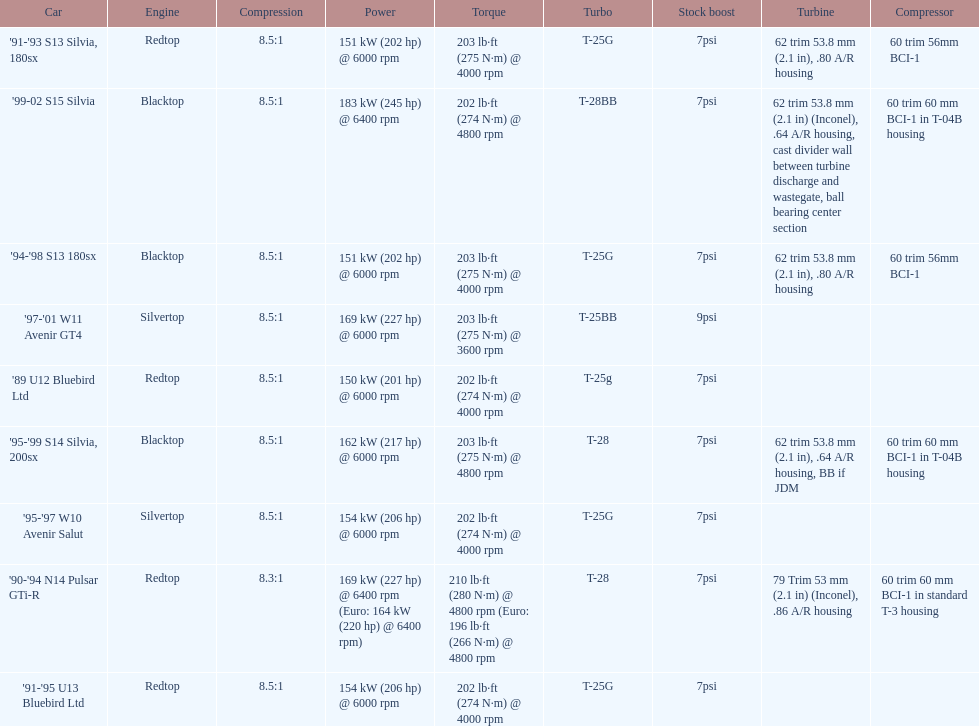Could you parse the entire table? {'header': ['Car', 'Engine', 'Compression', 'Power', 'Torque', 'Turbo', 'Stock boost', 'Turbine', 'Compressor'], 'rows': [["'91-'93 S13 Silvia, 180sx", 'Redtop', '8.5:1', '151\xa0kW (202\xa0hp) @ 6000 rpm', '203\xa0lb·ft (275\xa0N·m) @ 4000 rpm', 'T-25G', '7psi', '62 trim 53.8\xa0mm (2.1\xa0in), .80 A/R housing', '60 trim 56mm BCI-1'], ["'99-02 S15 Silvia", 'Blacktop', '8.5:1', '183\xa0kW (245\xa0hp) @ 6400 rpm', '202\xa0lb·ft (274\xa0N·m) @ 4800 rpm', 'T-28BB', '7psi', '62 trim 53.8\xa0mm (2.1\xa0in) (Inconel), .64 A/R housing, cast divider wall between turbine discharge and wastegate, ball bearing center section', '60 trim 60\xa0mm BCI-1 in T-04B housing'], ["'94-'98 S13 180sx", 'Blacktop', '8.5:1', '151\xa0kW (202\xa0hp) @ 6000 rpm', '203\xa0lb·ft (275\xa0N·m) @ 4000 rpm', 'T-25G', '7psi', '62 trim 53.8\xa0mm (2.1\xa0in), .80 A/R housing', '60 trim 56mm BCI-1'], ["'97-'01 W11 Avenir GT4", 'Silvertop', '8.5:1', '169\xa0kW (227\xa0hp) @ 6000 rpm', '203\xa0lb·ft (275\xa0N·m) @ 3600 rpm', 'T-25BB', '9psi', '', ''], ["'89 U12 Bluebird Ltd", 'Redtop', '8.5:1', '150\xa0kW (201\xa0hp) @ 6000 rpm', '202\xa0lb·ft (274\xa0N·m) @ 4000 rpm', 'T-25g', '7psi', '', ''], ["'95-'99 S14 Silvia, 200sx", 'Blacktop', '8.5:1', '162\xa0kW (217\xa0hp) @ 6000 rpm', '203\xa0lb·ft (275\xa0N·m) @ 4800 rpm', 'T-28', '7psi', '62 trim 53.8\xa0mm (2.1\xa0in), .64 A/R housing, BB if JDM', '60 trim 60\xa0mm BCI-1 in T-04B housing'], ["'95-'97 W10 Avenir Salut", 'Silvertop', '8.5:1', '154\xa0kW (206\xa0hp) @ 6000 rpm', '202\xa0lb·ft (274\xa0N·m) @ 4000 rpm', 'T-25G', '7psi', '', ''], ["'90-'94 N14 Pulsar GTi-R", 'Redtop', '8.3:1', '169\xa0kW (227\xa0hp) @ 6400 rpm (Euro: 164\xa0kW (220\xa0hp) @ 6400 rpm)', '210\xa0lb·ft (280\xa0N·m) @ 4800 rpm (Euro: 196\xa0lb·ft (266\xa0N·m) @ 4800 rpm', 'T-28', '7psi', '79 Trim 53\xa0mm (2.1\xa0in) (Inconel), .86 A/R housing', '60 trim 60\xa0mm BCI-1 in standard T-3 housing'], ["'91-'95 U13 Bluebird Ltd", 'Redtop', '8.5:1', '154\xa0kW (206\xa0hp) @ 6000 rpm', '202\xa0lb·ft (274\xa0N·m) @ 4000 rpm', 'T-25G', '7psi', '', '']]} What is his/her compression for the 90-94 n14 pulsar gti-r? 8.3:1. 